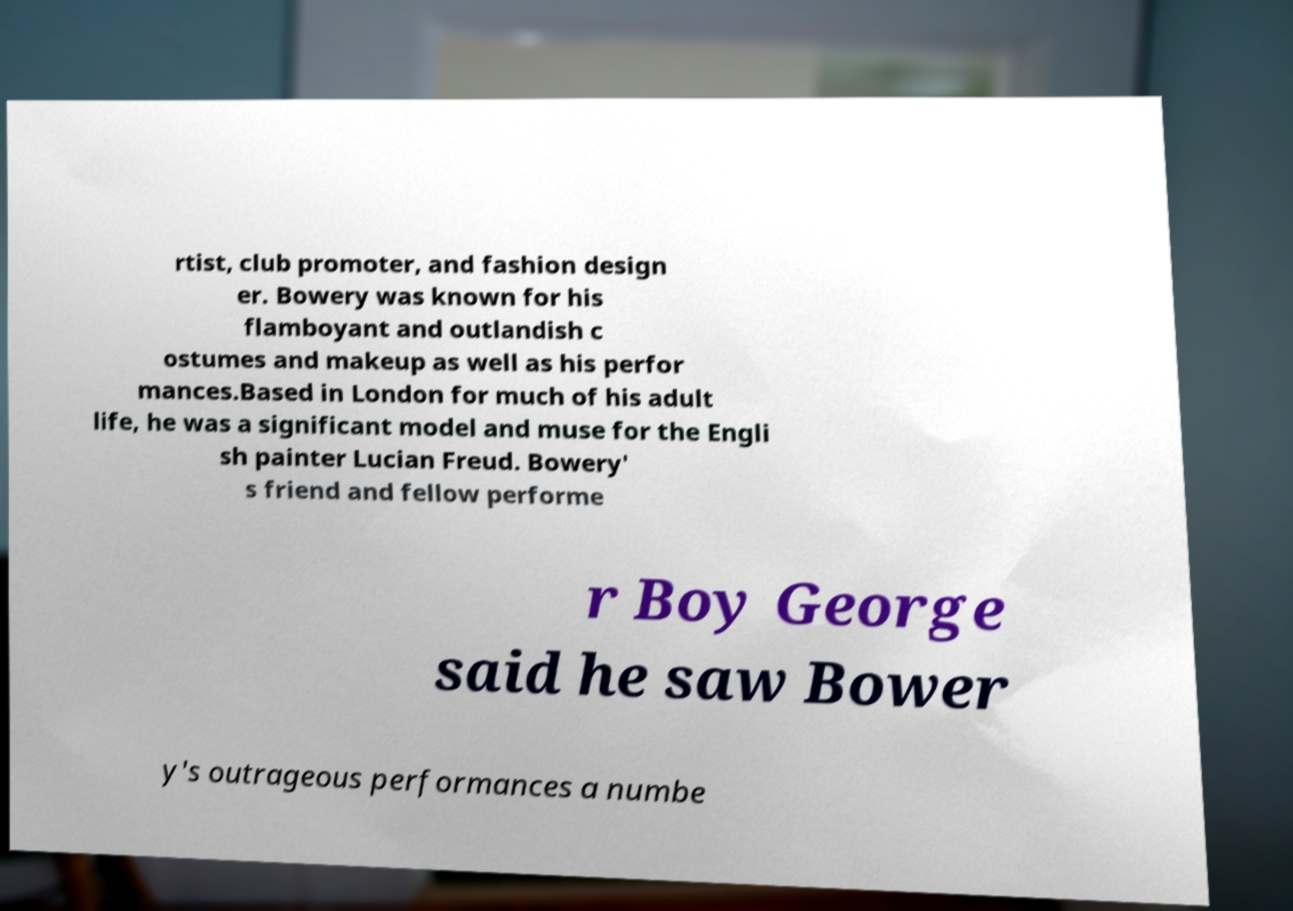Can you read and provide the text displayed in the image?This photo seems to have some interesting text. Can you extract and type it out for me? rtist, club promoter, and fashion design er. Bowery was known for his flamboyant and outlandish c ostumes and makeup as well as his perfor mances.Based in London for much of his adult life, he was a significant model and muse for the Engli sh painter Lucian Freud. Bowery' s friend and fellow performe r Boy George said he saw Bower y's outrageous performances a numbe 